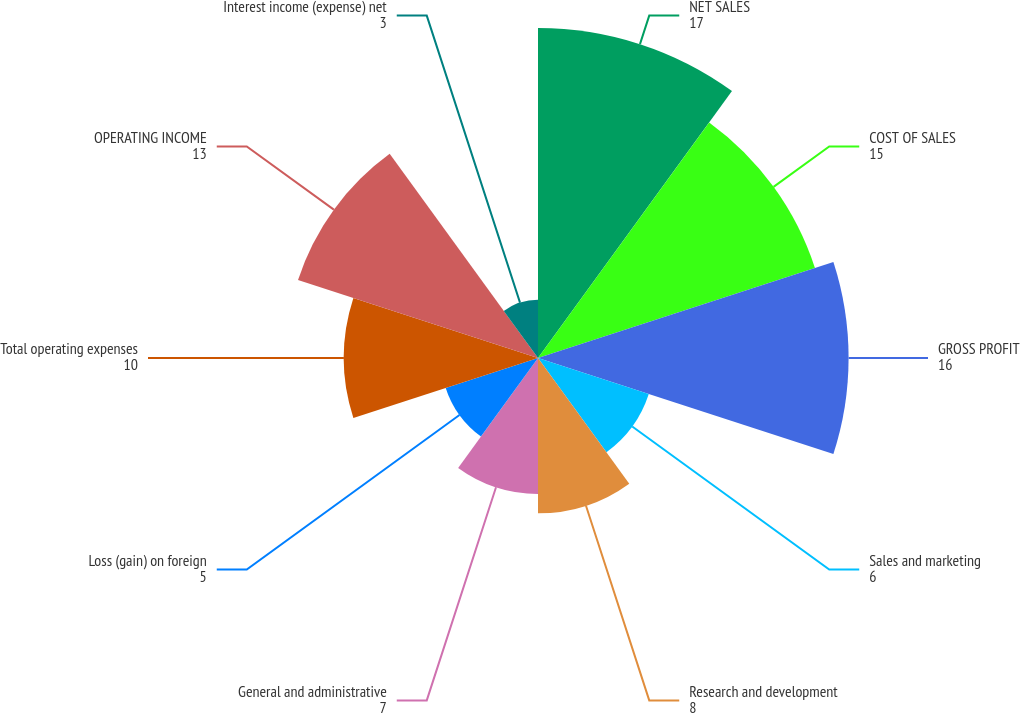Convert chart to OTSL. <chart><loc_0><loc_0><loc_500><loc_500><pie_chart><fcel>NET SALES<fcel>COST OF SALES<fcel>GROSS PROFIT<fcel>Sales and marketing<fcel>Research and development<fcel>General and administrative<fcel>Loss (gain) on foreign<fcel>Total operating expenses<fcel>OPERATING INCOME<fcel>Interest income (expense) net<nl><fcel>17.0%<fcel>15.0%<fcel>16.0%<fcel>6.0%<fcel>8.0%<fcel>7.0%<fcel>5.0%<fcel>10.0%<fcel>13.0%<fcel>3.0%<nl></chart> 